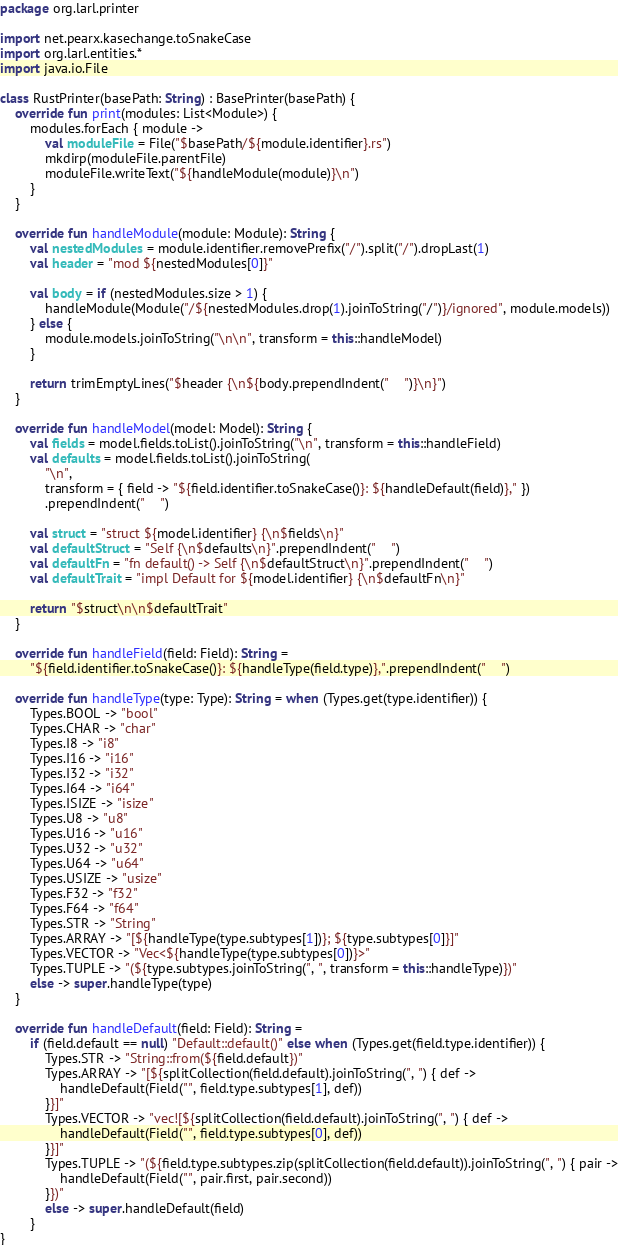<code> <loc_0><loc_0><loc_500><loc_500><_Kotlin_>package org.larl.printer

import net.pearx.kasechange.toSnakeCase
import org.larl.entities.*
import java.io.File

class RustPrinter(basePath: String) : BasePrinter(basePath) {
    override fun print(modules: List<Module>) {
        modules.forEach { module ->
            val moduleFile = File("$basePath/${module.identifier}.rs")
            mkdirp(moduleFile.parentFile)
            moduleFile.writeText("${handleModule(module)}\n")
        }
    }

    override fun handleModule(module: Module): String {
        val nestedModules = module.identifier.removePrefix("/").split("/").dropLast(1)
        val header = "mod ${nestedModules[0]}"

        val body = if (nestedModules.size > 1) {
            handleModule(Module("/${nestedModules.drop(1).joinToString("/")}/ignored", module.models))
        } else {
            module.models.joinToString("\n\n", transform = this::handleModel)
        }

        return trimEmptyLines("$header {\n${body.prependIndent("    ")}\n}")
    }

    override fun handleModel(model: Model): String {
        val fields = model.fields.toList().joinToString("\n", transform = this::handleField)
        val defaults = model.fields.toList().joinToString(
            "\n",
            transform = { field -> "${field.identifier.toSnakeCase()}: ${handleDefault(field)}," })
            .prependIndent("    ")

        val struct = "struct ${model.identifier} {\n$fields\n}"
        val defaultStruct = "Self {\n$defaults\n}".prependIndent("    ")
        val defaultFn = "fn default() -> Self {\n$defaultStruct\n}".prependIndent("    ")
        val defaultTrait = "impl Default for ${model.identifier} {\n$defaultFn\n}"

        return "$struct\n\n$defaultTrait"
    }

    override fun handleField(field: Field): String =
        "${field.identifier.toSnakeCase()}: ${handleType(field.type)},".prependIndent("    ")

    override fun handleType(type: Type): String = when (Types.get(type.identifier)) {
        Types.BOOL -> "bool"
        Types.CHAR -> "char"
        Types.I8 -> "i8"
        Types.I16 -> "i16"
        Types.I32 -> "i32"
        Types.I64 -> "i64"
        Types.ISIZE -> "isize"
        Types.U8 -> "u8"
        Types.U16 -> "u16"
        Types.U32 -> "u32"
        Types.U64 -> "u64"
        Types.USIZE -> "usize"
        Types.F32 -> "f32"
        Types.F64 -> "f64"
        Types.STR -> "String"
        Types.ARRAY -> "[${handleType(type.subtypes[1])}; ${type.subtypes[0]}]"
        Types.VECTOR -> "Vec<${handleType(type.subtypes[0])}>"
        Types.TUPLE -> "(${type.subtypes.joinToString(", ", transform = this::handleType)})"
        else -> super.handleType(type)
    }

    override fun handleDefault(field: Field): String =
        if (field.default == null) "Default::default()" else when (Types.get(field.type.identifier)) {
            Types.STR -> "String::from(${field.default})"
            Types.ARRAY -> "[${splitCollection(field.default).joinToString(", ") { def ->
                handleDefault(Field("", field.type.subtypes[1], def))
            }}]"
            Types.VECTOR -> "vec![${splitCollection(field.default).joinToString(", ") { def ->
                handleDefault(Field("", field.type.subtypes[0], def))
            }}]"
            Types.TUPLE -> "(${field.type.subtypes.zip(splitCollection(field.default)).joinToString(", ") { pair ->
                handleDefault(Field("", pair.first, pair.second))
            }})"
            else -> super.handleDefault(field)
        }
}
</code> 